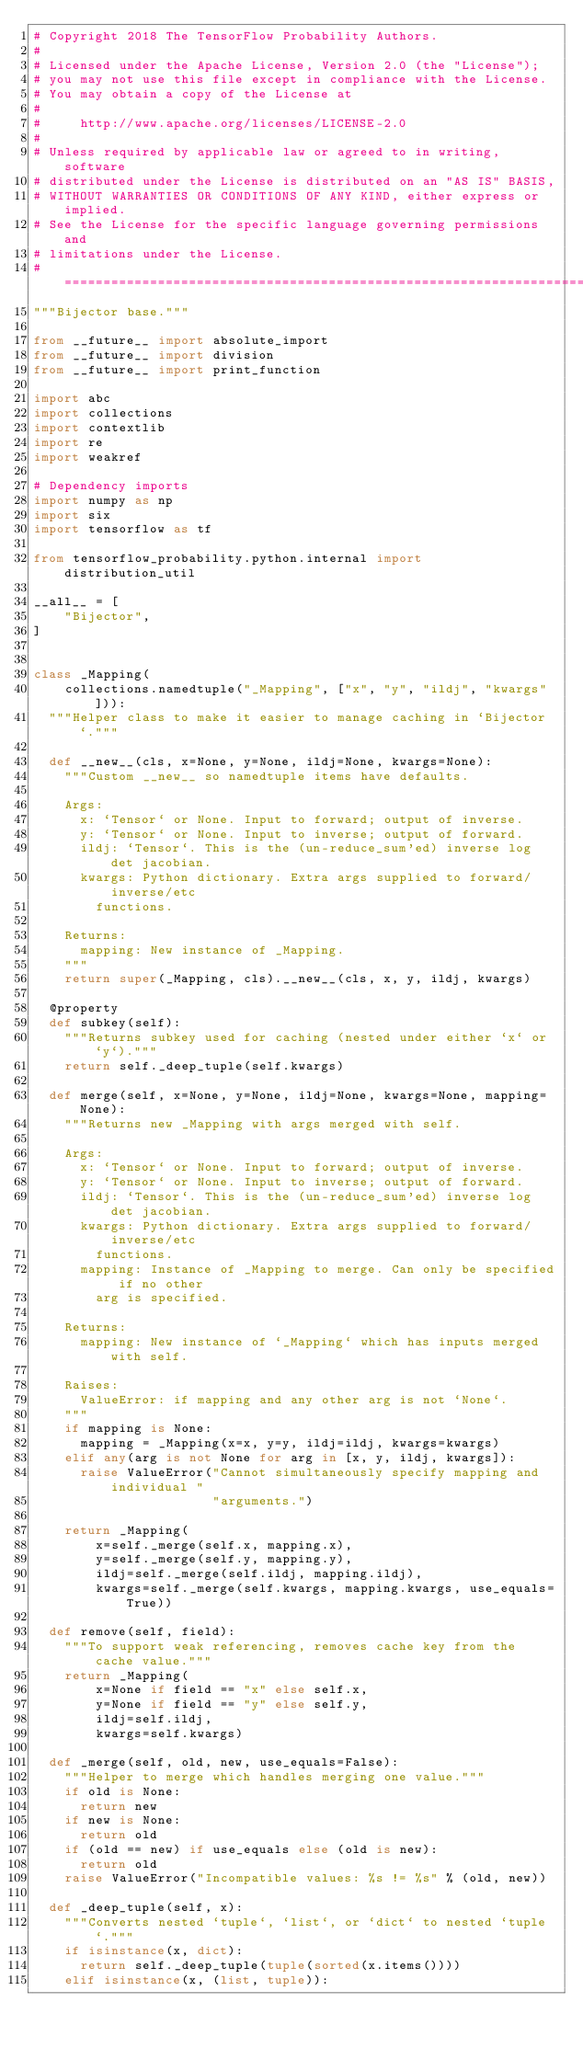<code> <loc_0><loc_0><loc_500><loc_500><_Python_># Copyright 2018 The TensorFlow Probability Authors.
#
# Licensed under the Apache License, Version 2.0 (the "License");
# you may not use this file except in compliance with the License.
# You may obtain a copy of the License at
#
#     http://www.apache.org/licenses/LICENSE-2.0
#
# Unless required by applicable law or agreed to in writing, software
# distributed under the License is distributed on an "AS IS" BASIS,
# WITHOUT WARRANTIES OR CONDITIONS OF ANY KIND, either express or implied.
# See the License for the specific language governing permissions and
# limitations under the License.
# ============================================================================
"""Bijector base."""

from __future__ import absolute_import
from __future__ import division
from __future__ import print_function

import abc
import collections
import contextlib
import re
import weakref

# Dependency imports
import numpy as np
import six
import tensorflow as tf

from tensorflow_probability.python.internal import distribution_util

__all__ = [
    "Bijector",
]


class _Mapping(
    collections.namedtuple("_Mapping", ["x", "y", "ildj", "kwargs"])):
  """Helper class to make it easier to manage caching in `Bijector`."""

  def __new__(cls, x=None, y=None, ildj=None, kwargs=None):
    """Custom __new__ so namedtuple items have defaults.

    Args:
      x: `Tensor` or None. Input to forward; output of inverse.
      y: `Tensor` or None. Input to inverse; output of forward.
      ildj: `Tensor`. This is the (un-reduce_sum'ed) inverse log det jacobian.
      kwargs: Python dictionary. Extra args supplied to forward/inverse/etc
        functions.

    Returns:
      mapping: New instance of _Mapping.
    """
    return super(_Mapping, cls).__new__(cls, x, y, ildj, kwargs)

  @property
  def subkey(self):
    """Returns subkey used for caching (nested under either `x` or `y`)."""
    return self._deep_tuple(self.kwargs)

  def merge(self, x=None, y=None, ildj=None, kwargs=None, mapping=None):
    """Returns new _Mapping with args merged with self.

    Args:
      x: `Tensor` or None. Input to forward; output of inverse.
      y: `Tensor` or None. Input to inverse; output of forward.
      ildj: `Tensor`. This is the (un-reduce_sum'ed) inverse log det jacobian.
      kwargs: Python dictionary. Extra args supplied to forward/inverse/etc
        functions.
      mapping: Instance of _Mapping to merge. Can only be specified if no other
        arg is specified.

    Returns:
      mapping: New instance of `_Mapping` which has inputs merged with self.

    Raises:
      ValueError: if mapping and any other arg is not `None`.
    """
    if mapping is None:
      mapping = _Mapping(x=x, y=y, ildj=ildj, kwargs=kwargs)
    elif any(arg is not None for arg in [x, y, ildj, kwargs]):
      raise ValueError("Cannot simultaneously specify mapping and individual "
                       "arguments.")

    return _Mapping(
        x=self._merge(self.x, mapping.x),
        y=self._merge(self.y, mapping.y),
        ildj=self._merge(self.ildj, mapping.ildj),
        kwargs=self._merge(self.kwargs, mapping.kwargs, use_equals=True))

  def remove(self, field):
    """To support weak referencing, removes cache key from the cache value."""
    return _Mapping(
        x=None if field == "x" else self.x,
        y=None if field == "y" else self.y,
        ildj=self.ildj,
        kwargs=self.kwargs)

  def _merge(self, old, new, use_equals=False):
    """Helper to merge which handles merging one value."""
    if old is None:
      return new
    if new is None:
      return old
    if (old == new) if use_equals else (old is new):
      return old
    raise ValueError("Incompatible values: %s != %s" % (old, new))

  def _deep_tuple(self, x):
    """Converts nested `tuple`, `list`, or `dict` to nested `tuple`."""
    if isinstance(x, dict):
      return self._deep_tuple(tuple(sorted(x.items())))
    elif isinstance(x, (list, tuple)):</code> 